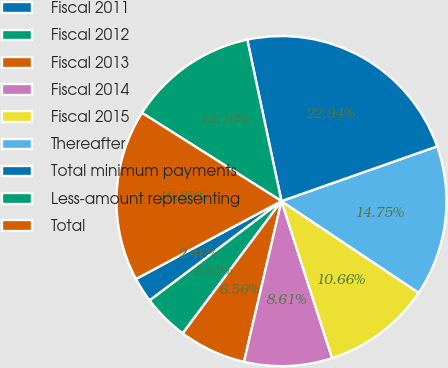<chart> <loc_0><loc_0><loc_500><loc_500><pie_chart><fcel>Fiscal 2011<fcel>Fiscal 2012<fcel>Fiscal 2013<fcel>Fiscal 2014<fcel>Fiscal 2015<fcel>Thereafter<fcel>Total minimum payments<fcel>Less-amount representing<fcel>Total<nl><fcel>2.46%<fcel>4.51%<fcel>6.56%<fcel>8.61%<fcel>10.66%<fcel>14.75%<fcel>22.94%<fcel>12.7%<fcel>16.8%<nl></chart> 